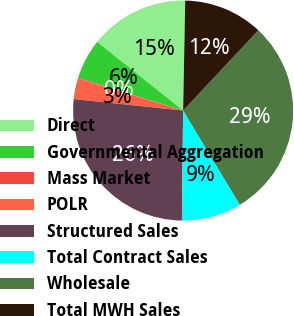Convert chart to OTSL. <chart><loc_0><loc_0><loc_500><loc_500><pie_chart><fcel>Direct<fcel>Governmental Aggregation<fcel>Mass Market<fcel>POLR<fcel>Structured Sales<fcel>Total Contract Sales<fcel>Wholesale<fcel>Total MWH Sales<nl><fcel>14.58%<fcel>5.91%<fcel>0.13%<fcel>3.02%<fcel>26.49%<fcel>8.8%<fcel>29.38%<fcel>11.69%<nl></chart> 